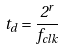Convert formula to latex. <formula><loc_0><loc_0><loc_500><loc_500>t _ { d } = \frac { 2 ^ { r } } { f _ { c l k } }</formula> 